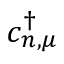<formula> <loc_0><loc_0><loc_500><loc_500>c _ { n , \mu } ^ { \dagger }</formula> 